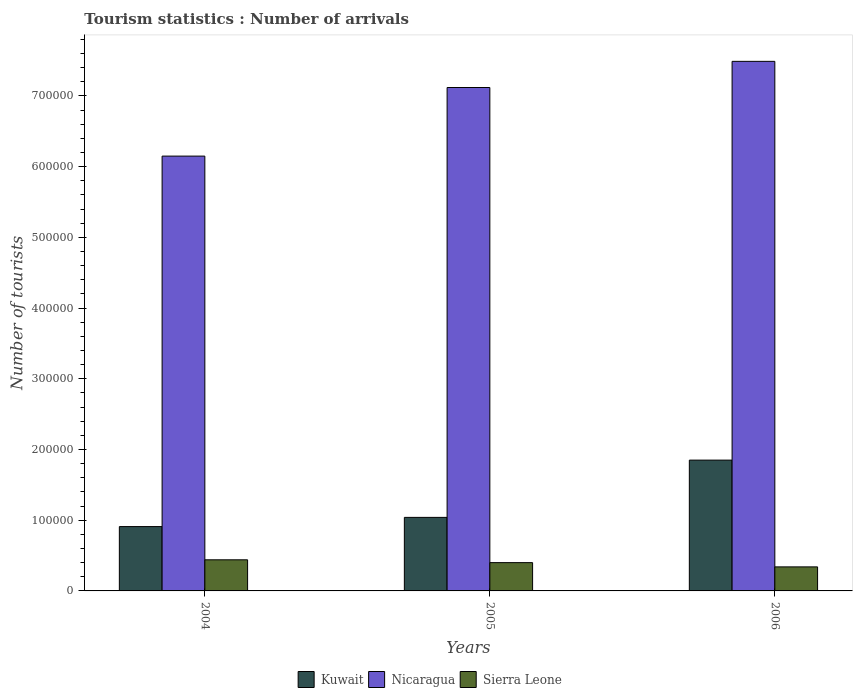Are the number of bars per tick equal to the number of legend labels?
Keep it short and to the point. Yes. Are the number of bars on each tick of the X-axis equal?
Ensure brevity in your answer.  Yes. How many bars are there on the 1st tick from the left?
Provide a succinct answer. 3. What is the label of the 3rd group of bars from the left?
Your answer should be compact. 2006. What is the number of tourist arrivals in Kuwait in 2006?
Your response must be concise. 1.85e+05. Across all years, what is the maximum number of tourist arrivals in Nicaragua?
Ensure brevity in your answer.  7.49e+05. Across all years, what is the minimum number of tourist arrivals in Nicaragua?
Offer a terse response. 6.15e+05. What is the total number of tourist arrivals in Sierra Leone in the graph?
Provide a succinct answer. 1.18e+05. What is the difference between the number of tourist arrivals in Nicaragua in 2004 and that in 2005?
Provide a short and direct response. -9.70e+04. What is the difference between the number of tourist arrivals in Kuwait in 2005 and the number of tourist arrivals in Nicaragua in 2006?
Offer a very short reply. -6.45e+05. What is the average number of tourist arrivals in Kuwait per year?
Offer a very short reply. 1.27e+05. In the year 2006, what is the difference between the number of tourist arrivals in Sierra Leone and number of tourist arrivals in Nicaragua?
Your answer should be very brief. -7.15e+05. What is the ratio of the number of tourist arrivals in Nicaragua in 2004 to that in 2005?
Your answer should be very brief. 0.86. What is the difference between the highest and the second highest number of tourist arrivals in Kuwait?
Your answer should be very brief. 8.10e+04. What is the difference between the highest and the lowest number of tourist arrivals in Nicaragua?
Provide a short and direct response. 1.34e+05. In how many years, is the number of tourist arrivals in Kuwait greater than the average number of tourist arrivals in Kuwait taken over all years?
Offer a very short reply. 1. What does the 2nd bar from the left in 2005 represents?
Keep it short and to the point. Nicaragua. What does the 3rd bar from the right in 2005 represents?
Make the answer very short. Kuwait. How many bars are there?
Your response must be concise. 9. Are all the bars in the graph horizontal?
Give a very brief answer. No. How many years are there in the graph?
Keep it short and to the point. 3. What is the difference between two consecutive major ticks on the Y-axis?
Provide a short and direct response. 1.00e+05. Does the graph contain any zero values?
Your response must be concise. No. Where does the legend appear in the graph?
Provide a short and direct response. Bottom center. What is the title of the graph?
Your answer should be compact. Tourism statistics : Number of arrivals. What is the label or title of the Y-axis?
Offer a terse response. Number of tourists. What is the Number of tourists of Kuwait in 2004?
Provide a short and direct response. 9.10e+04. What is the Number of tourists of Nicaragua in 2004?
Provide a short and direct response. 6.15e+05. What is the Number of tourists in Sierra Leone in 2004?
Make the answer very short. 4.40e+04. What is the Number of tourists of Kuwait in 2005?
Provide a succinct answer. 1.04e+05. What is the Number of tourists in Nicaragua in 2005?
Give a very brief answer. 7.12e+05. What is the Number of tourists of Sierra Leone in 2005?
Provide a succinct answer. 4.00e+04. What is the Number of tourists of Kuwait in 2006?
Ensure brevity in your answer.  1.85e+05. What is the Number of tourists of Nicaragua in 2006?
Provide a succinct answer. 7.49e+05. What is the Number of tourists of Sierra Leone in 2006?
Your answer should be compact. 3.40e+04. Across all years, what is the maximum Number of tourists of Kuwait?
Your answer should be compact. 1.85e+05. Across all years, what is the maximum Number of tourists of Nicaragua?
Provide a succinct answer. 7.49e+05. Across all years, what is the maximum Number of tourists in Sierra Leone?
Provide a succinct answer. 4.40e+04. Across all years, what is the minimum Number of tourists of Kuwait?
Your answer should be very brief. 9.10e+04. Across all years, what is the minimum Number of tourists in Nicaragua?
Your response must be concise. 6.15e+05. Across all years, what is the minimum Number of tourists in Sierra Leone?
Your answer should be compact. 3.40e+04. What is the total Number of tourists of Nicaragua in the graph?
Provide a short and direct response. 2.08e+06. What is the total Number of tourists in Sierra Leone in the graph?
Ensure brevity in your answer.  1.18e+05. What is the difference between the Number of tourists in Kuwait in 2004 and that in 2005?
Your response must be concise. -1.30e+04. What is the difference between the Number of tourists in Nicaragua in 2004 and that in 2005?
Keep it short and to the point. -9.70e+04. What is the difference between the Number of tourists in Sierra Leone in 2004 and that in 2005?
Your response must be concise. 4000. What is the difference between the Number of tourists of Kuwait in 2004 and that in 2006?
Offer a terse response. -9.40e+04. What is the difference between the Number of tourists in Nicaragua in 2004 and that in 2006?
Your answer should be very brief. -1.34e+05. What is the difference between the Number of tourists in Kuwait in 2005 and that in 2006?
Ensure brevity in your answer.  -8.10e+04. What is the difference between the Number of tourists of Nicaragua in 2005 and that in 2006?
Make the answer very short. -3.70e+04. What is the difference between the Number of tourists of Sierra Leone in 2005 and that in 2006?
Make the answer very short. 6000. What is the difference between the Number of tourists in Kuwait in 2004 and the Number of tourists in Nicaragua in 2005?
Your answer should be very brief. -6.21e+05. What is the difference between the Number of tourists of Kuwait in 2004 and the Number of tourists of Sierra Leone in 2005?
Provide a short and direct response. 5.10e+04. What is the difference between the Number of tourists of Nicaragua in 2004 and the Number of tourists of Sierra Leone in 2005?
Your response must be concise. 5.75e+05. What is the difference between the Number of tourists in Kuwait in 2004 and the Number of tourists in Nicaragua in 2006?
Give a very brief answer. -6.58e+05. What is the difference between the Number of tourists of Kuwait in 2004 and the Number of tourists of Sierra Leone in 2006?
Make the answer very short. 5.70e+04. What is the difference between the Number of tourists in Nicaragua in 2004 and the Number of tourists in Sierra Leone in 2006?
Provide a succinct answer. 5.81e+05. What is the difference between the Number of tourists in Kuwait in 2005 and the Number of tourists in Nicaragua in 2006?
Your answer should be compact. -6.45e+05. What is the difference between the Number of tourists in Kuwait in 2005 and the Number of tourists in Sierra Leone in 2006?
Offer a terse response. 7.00e+04. What is the difference between the Number of tourists of Nicaragua in 2005 and the Number of tourists of Sierra Leone in 2006?
Your response must be concise. 6.78e+05. What is the average Number of tourists of Kuwait per year?
Provide a succinct answer. 1.27e+05. What is the average Number of tourists of Nicaragua per year?
Your answer should be very brief. 6.92e+05. What is the average Number of tourists of Sierra Leone per year?
Ensure brevity in your answer.  3.93e+04. In the year 2004, what is the difference between the Number of tourists of Kuwait and Number of tourists of Nicaragua?
Keep it short and to the point. -5.24e+05. In the year 2004, what is the difference between the Number of tourists of Kuwait and Number of tourists of Sierra Leone?
Keep it short and to the point. 4.70e+04. In the year 2004, what is the difference between the Number of tourists of Nicaragua and Number of tourists of Sierra Leone?
Make the answer very short. 5.71e+05. In the year 2005, what is the difference between the Number of tourists of Kuwait and Number of tourists of Nicaragua?
Offer a very short reply. -6.08e+05. In the year 2005, what is the difference between the Number of tourists in Kuwait and Number of tourists in Sierra Leone?
Offer a terse response. 6.40e+04. In the year 2005, what is the difference between the Number of tourists of Nicaragua and Number of tourists of Sierra Leone?
Provide a succinct answer. 6.72e+05. In the year 2006, what is the difference between the Number of tourists in Kuwait and Number of tourists in Nicaragua?
Provide a succinct answer. -5.64e+05. In the year 2006, what is the difference between the Number of tourists of Kuwait and Number of tourists of Sierra Leone?
Give a very brief answer. 1.51e+05. In the year 2006, what is the difference between the Number of tourists of Nicaragua and Number of tourists of Sierra Leone?
Ensure brevity in your answer.  7.15e+05. What is the ratio of the Number of tourists of Kuwait in 2004 to that in 2005?
Give a very brief answer. 0.88. What is the ratio of the Number of tourists of Nicaragua in 2004 to that in 2005?
Your answer should be compact. 0.86. What is the ratio of the Number of tourists of Kuwait in 2004 to that in 2006?
Make the answer very short. 0.49. What is the ratio of the Number of tourists of Nicaragua in 2004 to that in 2006?
Provide a succinct answer. 0.82. What is the ratio of the Number of tourists of Sierra Leone in 2004 to that in 2006?
Keep it short and to the point. 1.29. What is the ratio of the Number of tourists in Kuwait in 2005 to that in 2006?
Your answer should be very brief. 0.56. What is the ratio of the Number of tourists in Nicaragua in 2005 to that in 2006?
Make the answer very short. 0.95. What is the ratio of the Number of tourists of Sierra Leone in 2005 to that in 2006?
Offer a very short reply. 1.18. What is the difference between the highest and the second highest Number of tourists in Kuwait?
Keep it short and to the point. 8.10e+04. What is the difference between the highest and the second highest Number of tourists of Nicaragua?
Offer a very short reply. 3.70e+04. What is the difference between the highest and the second highest Number of tourists of Sierra Leone?
Make the answer very short. 4000. What is the difference between the highest and the lowest Number of tourists of Kuwait?
Ensure brevity in your answer.  9.40e+04. What is the difference between the highest and the lowest Number of tourists of Nicaragua?
Provide a succinct answer. 1.34e+05. What is the difference between the highest and the lowest Number of tourists of Sierra Leone?
Offer a terse response. 10000. 